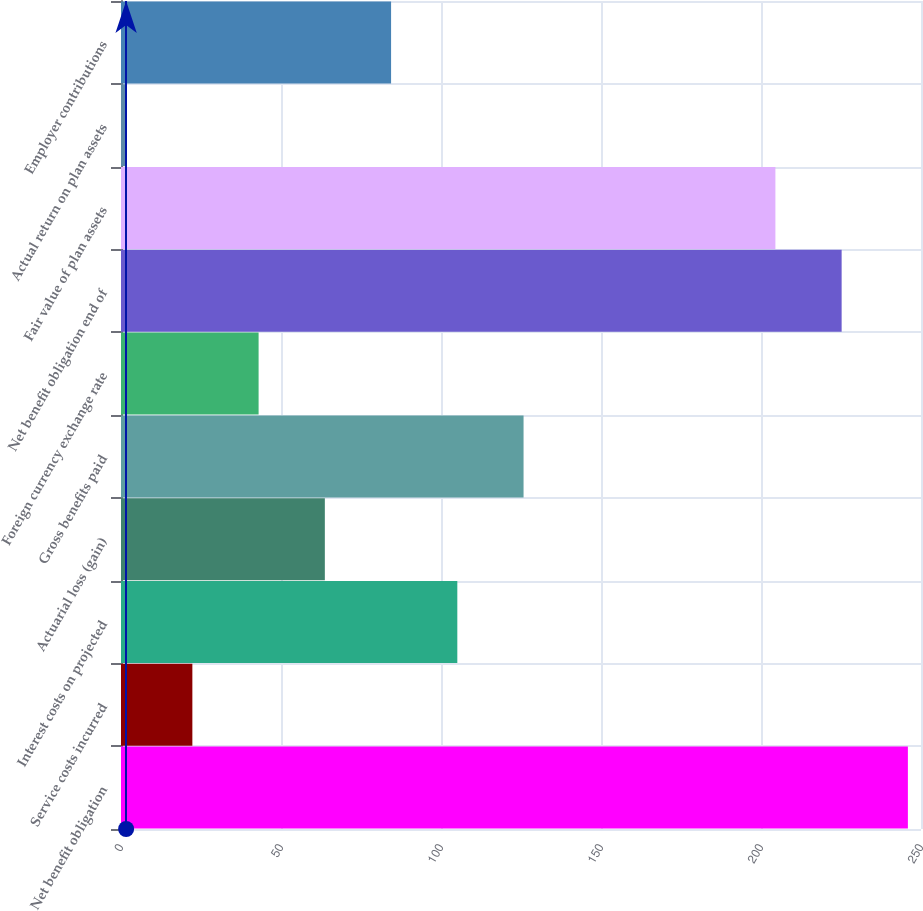<chart> <loc_0><loc_0><loc_500><loc_500><bar_chart><fcel>Net benefit obligation<fcel>Service costs incurred<fcel>Interest costs on projected<fcel>Actuarial loss (gain)<fcel>Gross benefits paid<fcel>Foreign currency exchange rate<fcel>Net benefit obligation end of<fcel>Fair value of plan assets<fcel>Actual return on plan assets<fcel>Employer contributions<nl><fcel>245.9<fcel>22.3<fcel>105.1<fcel>63.7<fcel>125.8<fcel>43<fcel>225.2<fcel>204.5<fcel>1.6<fcel>84.4<nl></chart> 